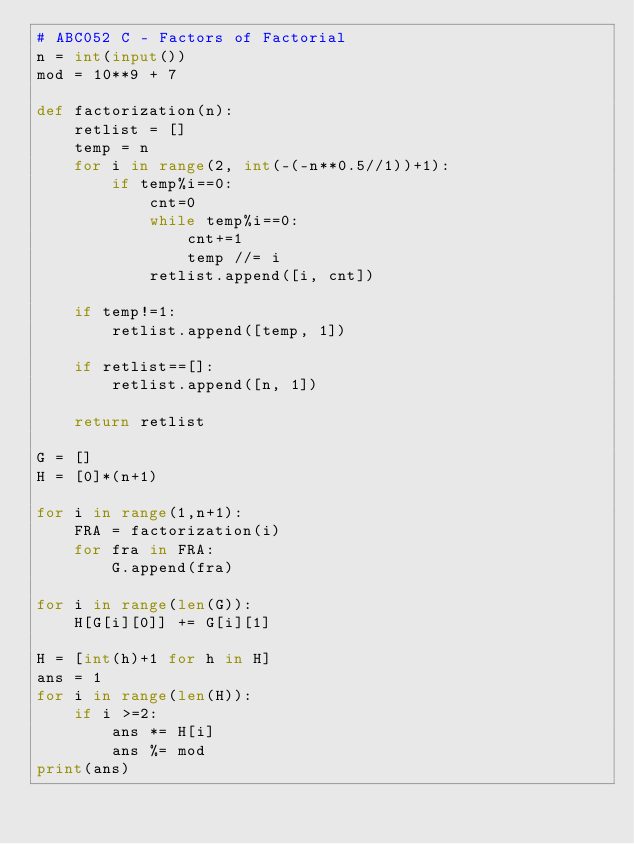Convert code to text. <code><loc_0><loc_0><loc_500><loc_500><_Python_># ABC052 C - Factors of Factorial
n = int(input())
mod = 10**9 + 7

def factorization(n):
    retlist = []
    temp = n
    for i in range(2, int(-(-n**0.5//1))+1):
        if temp%i==0:
            cnt=0
            while temp%i==0:
                cnt+=1
                temp //= i
            retlist.append([i, cnt])

    if temp!=1:
        retlist.append([temp, 1])

    if retlist==[]:
        retlist.append([n, 1])

    return retlist

G = []
H = [0]*(n+1)

for i in range(1,n+1):
    FRA = factorization(i)
    for fra in FRA:
        G.append(fra)

for i in range(len(G)):
    H[G[i][0]] += G[i][1]

H = [int(h)+1 for h in H]
ans = 1
for i in range(len(H)):
    if i >=2:
        ans *= H[i]
        ans %= mod
print(ans)</code> 